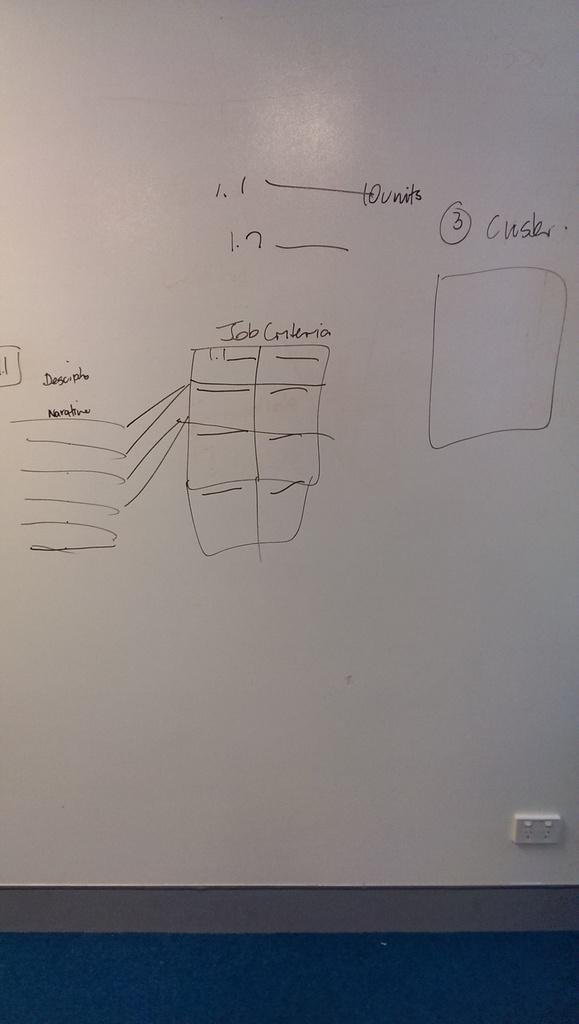Provide a one-sentence caption for the provided image. The whiteboard has a diagram depicting job criteria drawn on it. 